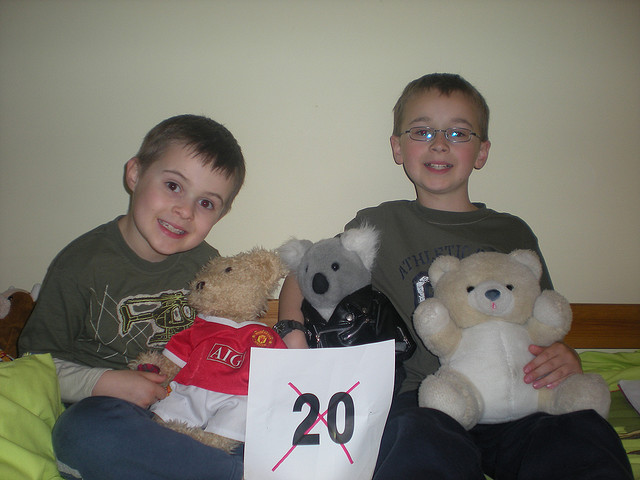How many bears are being held? 3 